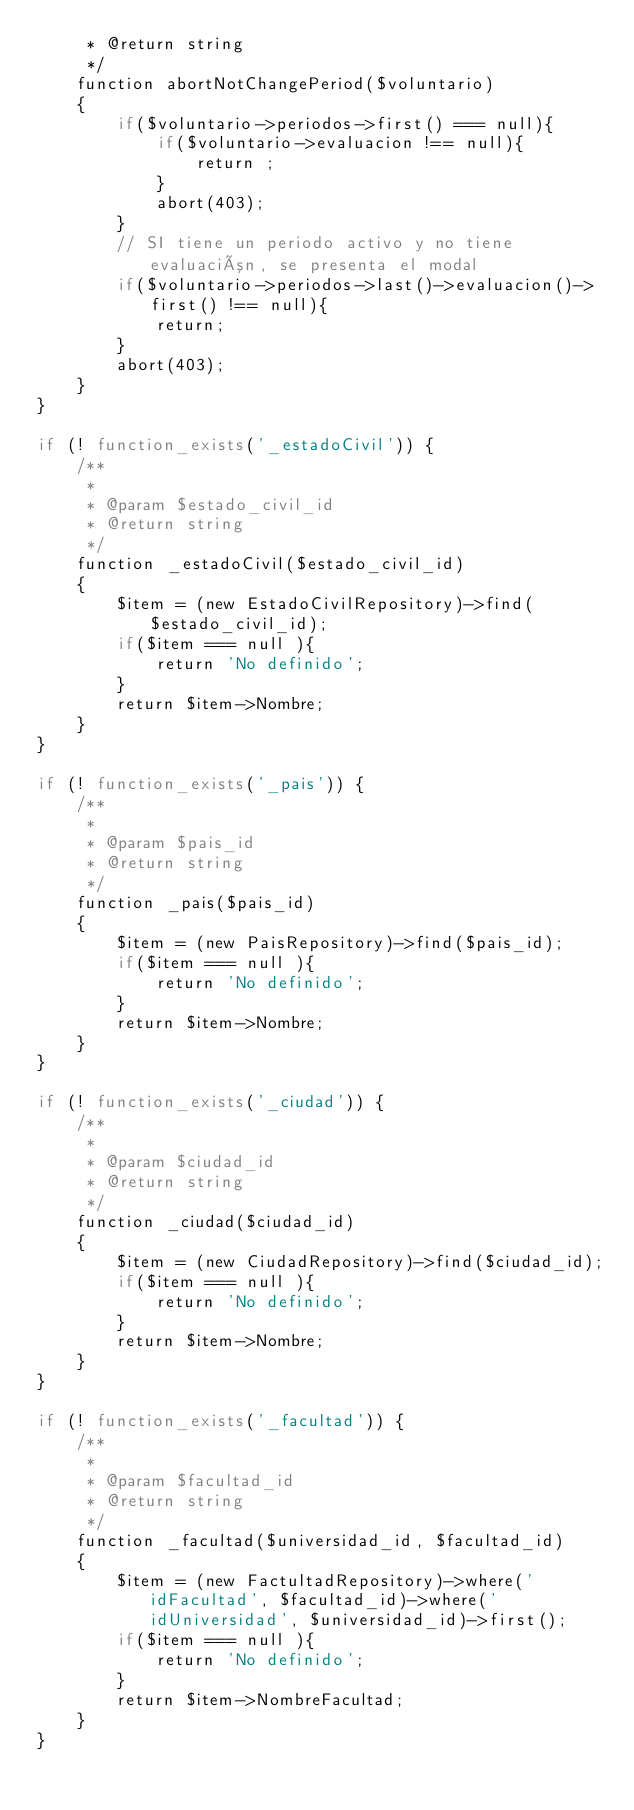<code> <loc_0><loc_0><loc_500><loc_500><_PHP_>     * @return string
     */
    function abortNotChangePeriod($voluntario)
    {
        if($voluntario->periodos->first() === null){
            if($voluntario->evaluacion !== null){
                return ;
            }
            abort(403);
        }
        // SI tiene un periodo activo y no tiene evaluación, se presenta el modal
        if($voluntario->periodos->last()->evaluacion()->first() !== null){
            return;
        }
        abort(403);
    }
}

if (! function_exists('_estadoCivil')) {
    /**
     *
     * @param $estado_civil_id
     * @return string
     */
    function _estadoCivil($estado_civil_id)
    {
        $item = (new EstadoCivilRepository)->find($estado_civil_id);
        if($item === null ){
            return 'No definido';
        }
        return $item->Nombre;
    }
}

if (! function_exists('_pais')) {
    /**
     *
     * @param $pais_id
     * @return string
     */
    function _pais($pais_id)
    {
        $item = (new PaisRepository)->find($pais_id);
        if($item === null ){
            return 'No definido';
        }
        return $item->Nombre;
    }
}

if (! function_exists('_ciudad')) {
    /**
     *
     * @param $ciudad_id
     * @return string
     */
    function _ciudad($ciudad_id)
    {
        $item = (new CiudadRepository)->find($ciudad_id);
        if($item === null ){
            return 'No definido';
        }
        return $item->Nombre;
    }
}

if (! function_exists('_facultad')) {
    /**
     *
     * @param $facultad_id
     * @return string
     */
    function _facultad($universidad_id, $facultad_id)
    {
        $item = (new FactultadRepository)->where('idFacultad', $facultad_id)->where('idUniversidad', $universidad_id)->first();
        if($item === null ){
            return 'No definido';
        }
        return $item->NombreFacultad;
    }
}</code> 